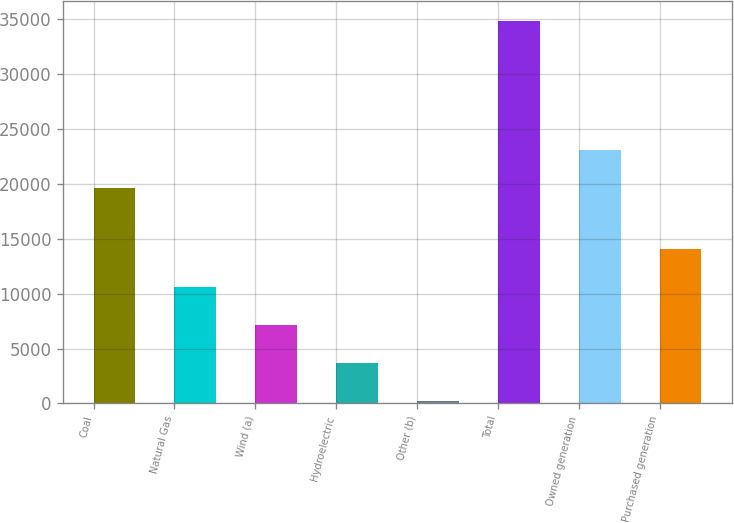<chart> <loc_0><loc_0><loc_500><loc_500><bar_chart><fcel>Coal<fcel>Natural Gas<fcel>Wind (a)<fcel>Hydroelectric<fcel>Other (b)<fcel>Total<fcel>Owned generation<fcel>Purchased generation<nl><fcel>19647<fcel>10635.1<fcel>7173.4<fcel>3711.7<fcel>250<fcel>34867<fcel>23108.7<fcel>14096.8<nl></chart> 